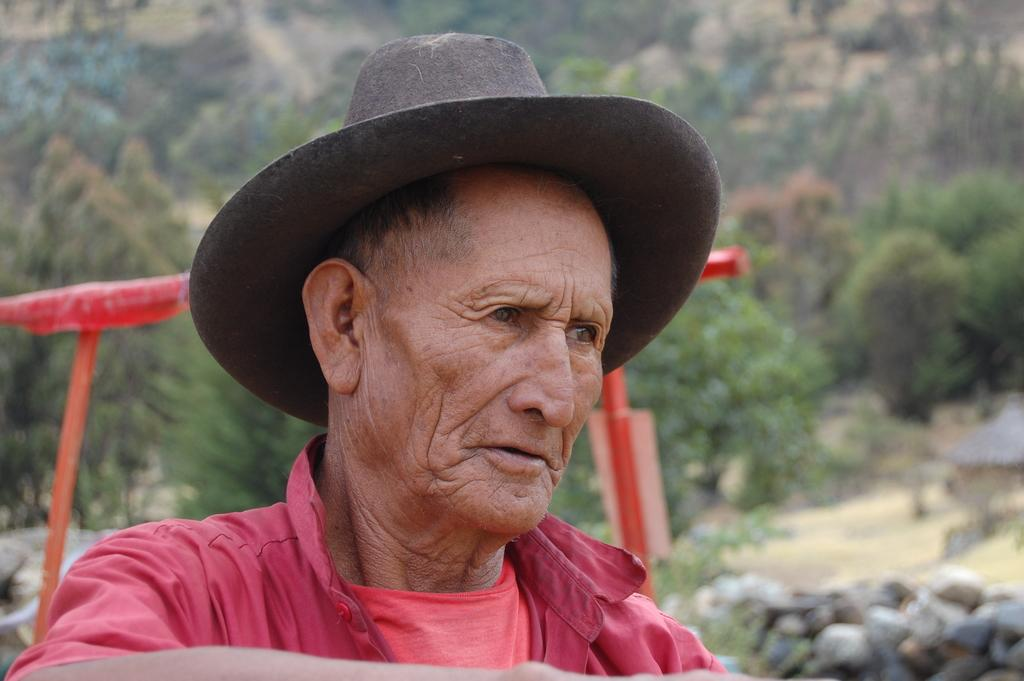Who is present in the image? There is a man in the picture. What is the man wearing on his head? The man is wearing a cap. What type of natural elements can be seen in the image? There are trees and rocks in the picture. What type of structure is visible on the right side of the image? There appears to be a hut on the right side of the picture. What color paint is the zebra using to decorate the hut in the image? There is no zebra present in the image, and therefore no paint or decoration can be observed. 